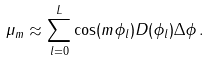Convert formula to latex. <formula><loc_0><loc_0><loc_500><loc_500>\mu _ { m } \approx \sum _ { l = 0 } ^ { L } \cos ( m \phi _ { l } ) D ( \phi _ { l } ) \Delta \phi \, .</formula> 